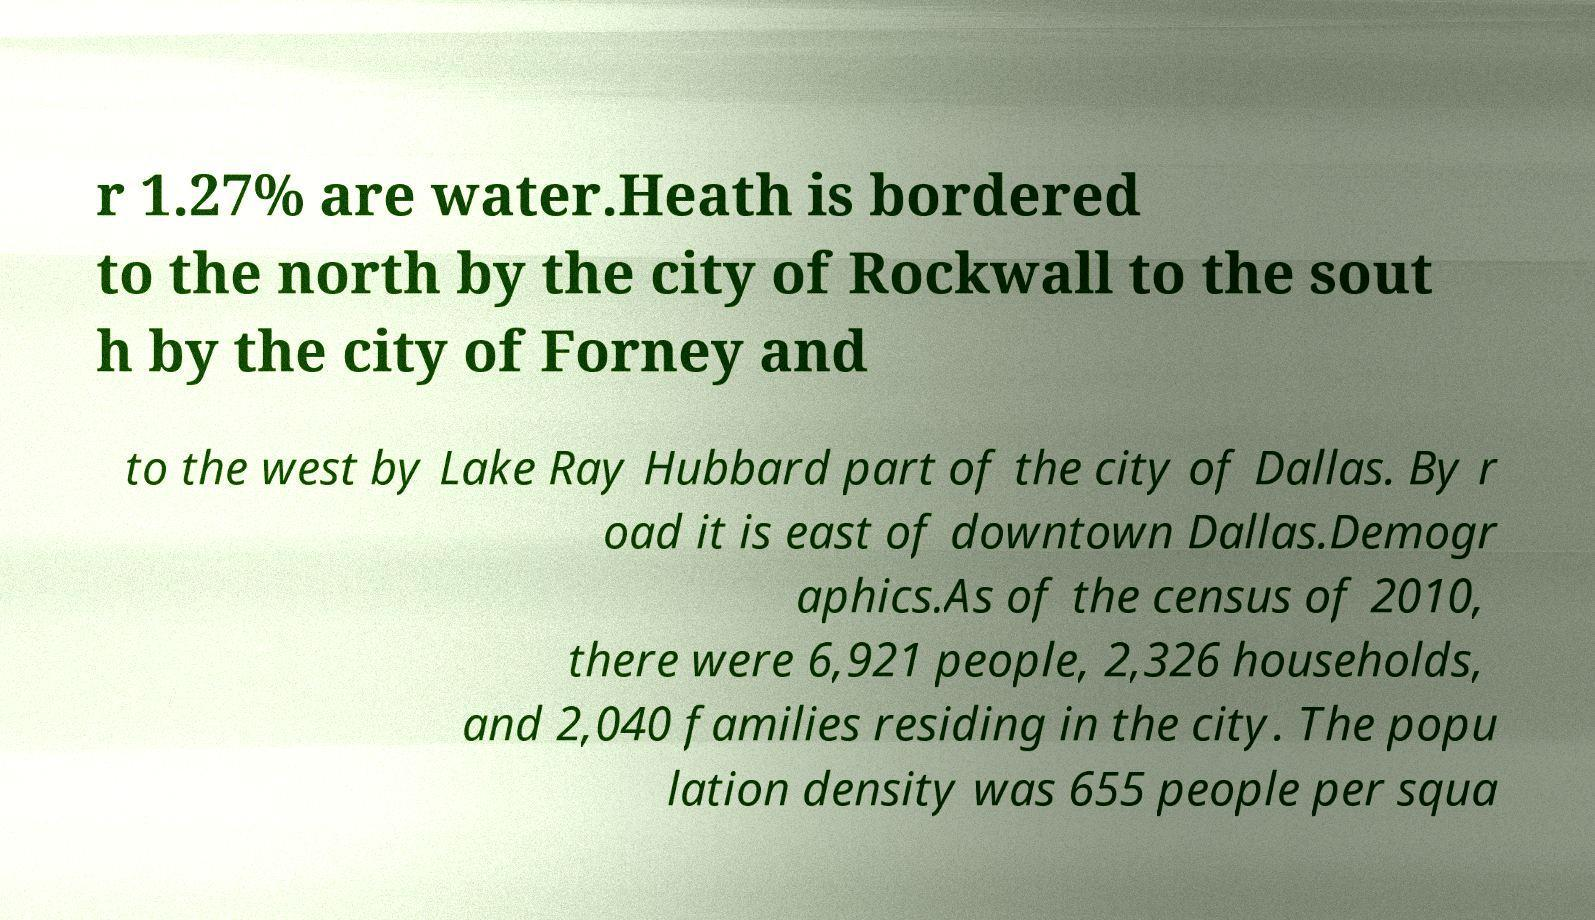For documentation purposes, I need the text within this image transcribed. Could you provide that? r 1.27% are water.Heath is bordered to the north by the city of Rockwall to the sout h by the city of Forney and to the west by Lake Ray Hubbard part of the city of Dallas. By r oad it is east of downtown Dallas.Demogr aphics.As of the census of 2010, there were 6,921 people, 2,326 households, and 2,040 families residing in the city. The popu lation density was 655 people per squa 